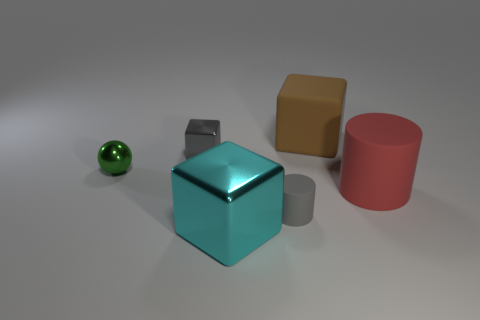Add 3 big brown blocks. How many objects exist? 9 Subtract all cylinders. How many objects are left? 4 Add 1 cyan metallic things. How many cyan metallic things exist? 2 Subtract 0 blue cylinders. How many objects are left? 6 Subtract all large cyan balls. Subtract all small gray metal things. How many objects are left? 5 Add 1 small matte cylinders. How many small matte cylinders are left? 2 